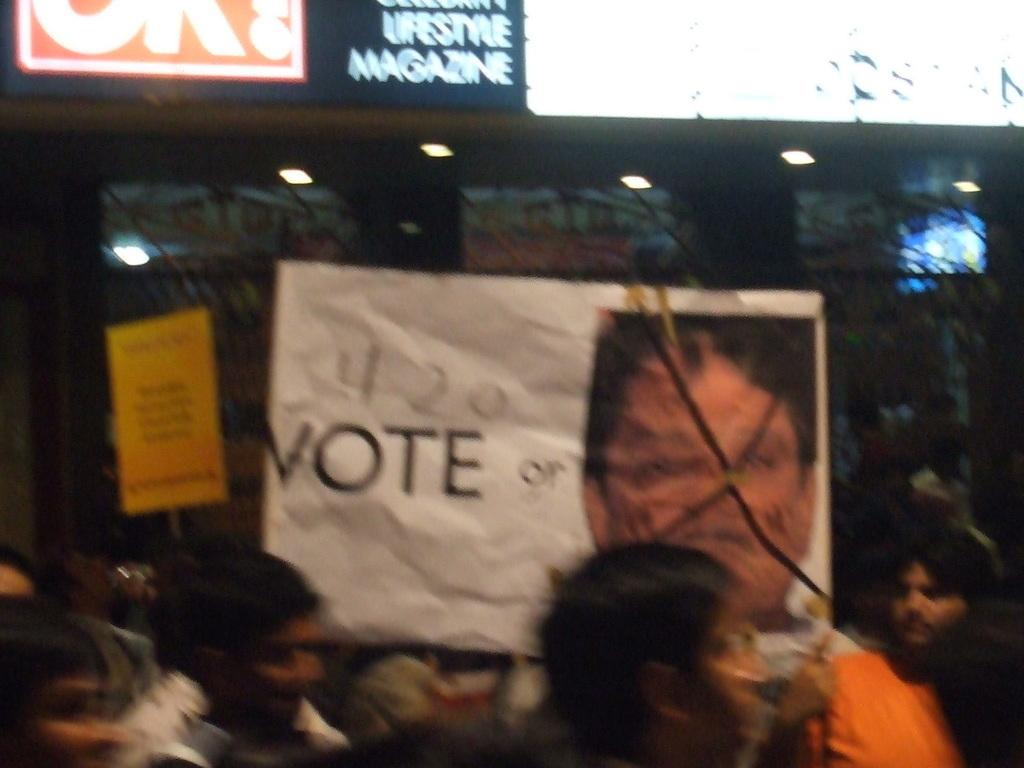How many people are in the image? There are people in the image, but the exact number is not specified. What are some people holding in the image? Some people are holding posters in the image. What can be found on the posters? The posters have text and images on them. Are there any special features on the posters? Yes, there are posters with lights in the image. What else can be seen in the image besides people and posters? There are lights visible in the image. What type of jar is being used to hold the popcorn in the image? There is no jar or popcorn present in the image. Can you describe the sock that is being worn by one of the people in the image? There is no mention of socks or any clothing details in the image. 